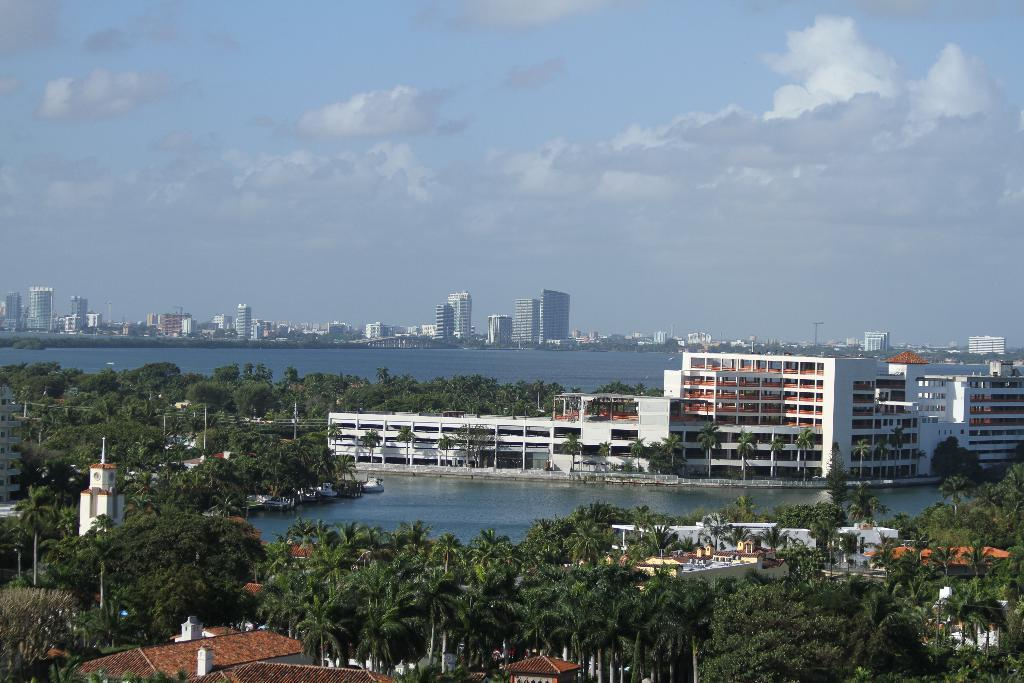What type of structures can be seen in the image? There are buildings in the image. What natural elements are present in the image? There are trees and water visible in the image. What is visible in the background of the image? The sky is visible in the background of the image. What objects can be seen supporting wires or other items in the image? There are poles in the image. Can you see any cherries growing on the trees in the image? There are no cherries visible in the image; the trees are not specified as cherry trees. 